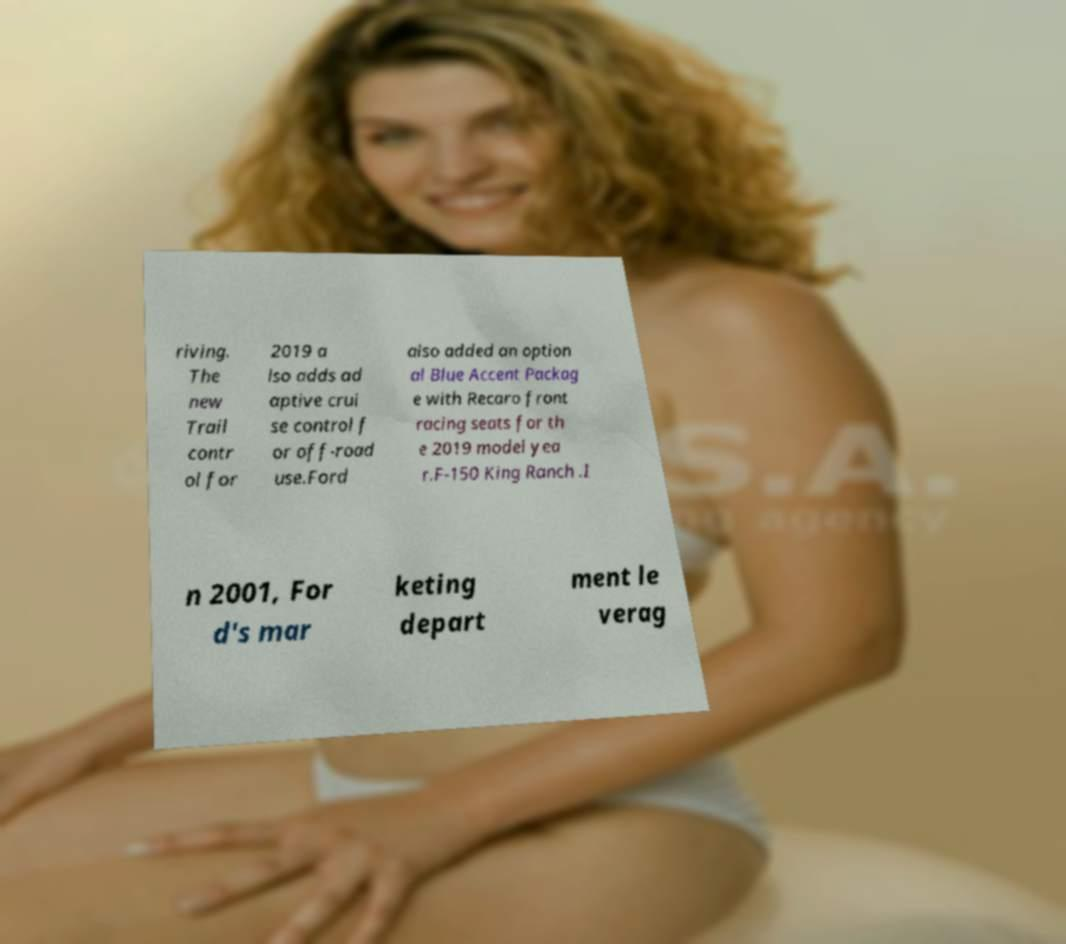Can you accurately transcribe the text from the provided image for me? riving. The new Trail contr ol for 2019 a lso adds ad aptive crui se control f or off-road use.Ford also added an option al Blue Accent Packag e with Recaro front racing seats for th e 2019 model yea r.F-150 King Ranch .I n 2001, For d's mar keting depart ment le verag 